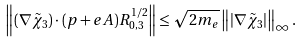<formula> <loc_0><loc_0><loc_500><loc_500>\left \| ( \nabla { \tilde { \chi } } _ { 3 } ) \cdot ( { p } + e { A } ) R _ { 0 , 3 } ^ { 1 / 2 } \right \| \leq \sqrt { 2 m _ { e } } \left \| | \nabla { \tilde { \chi } } _ { 3 } | \right \| _ { \infty } .</formula> 